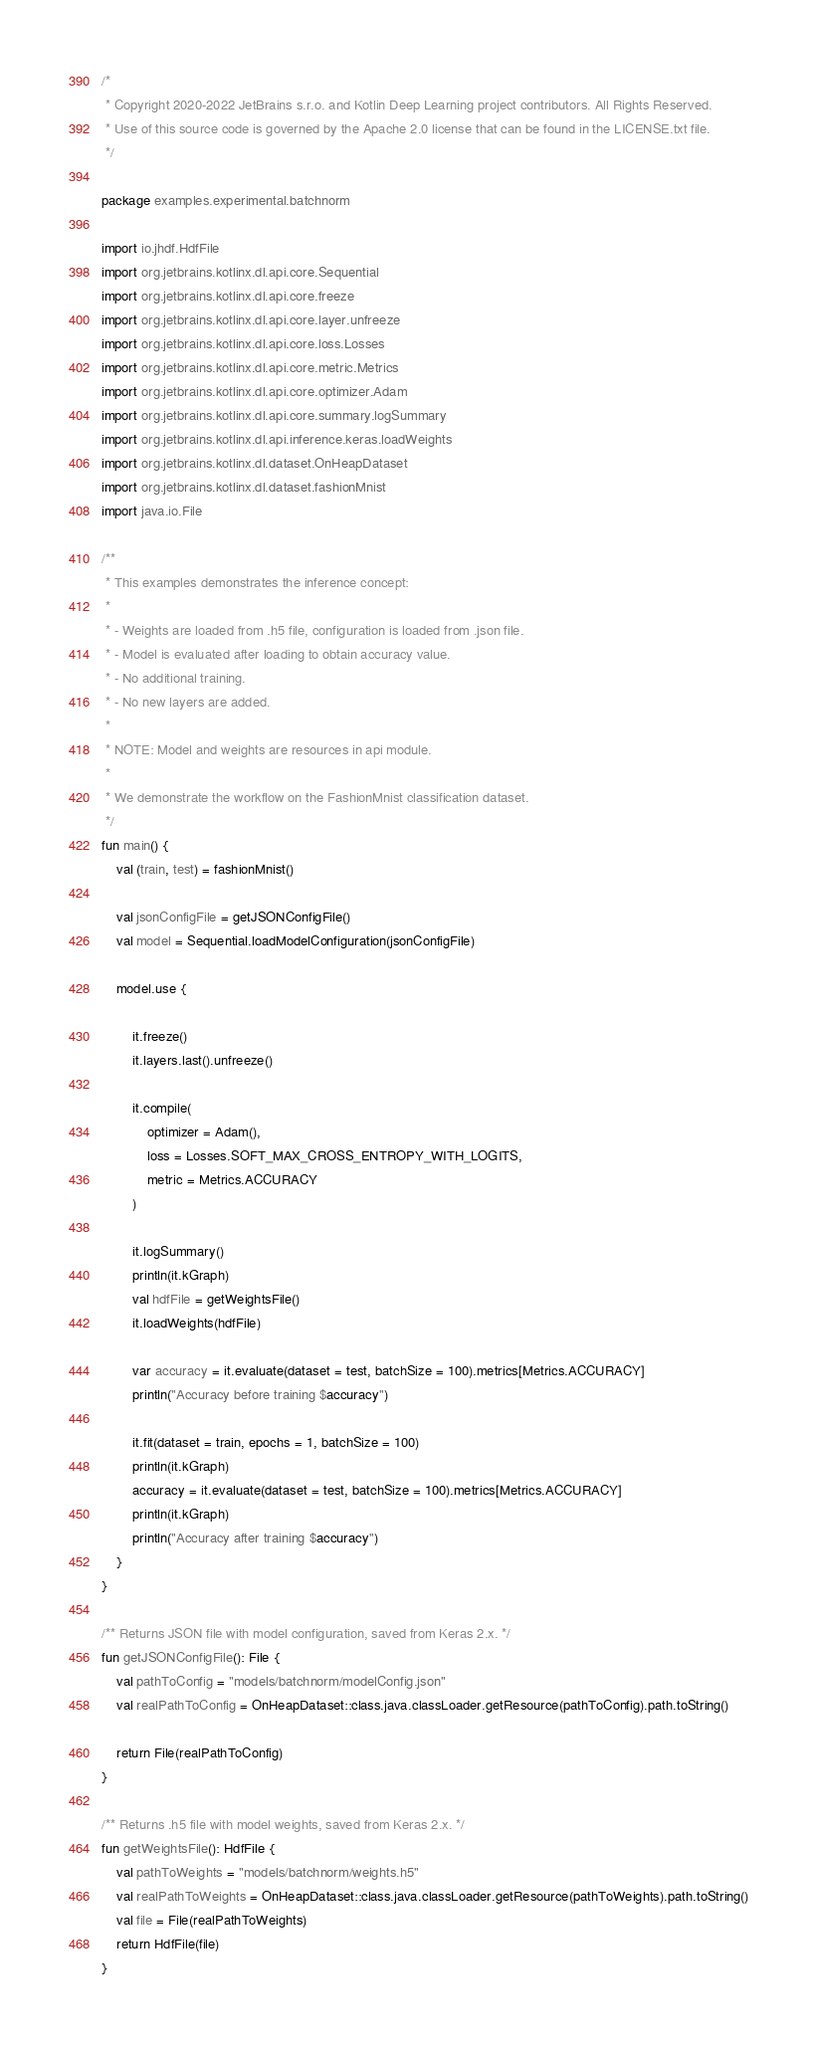<code> <loc_0><loc_0><loc_500><loc_500><_Kotlin_>/*
 * Copyright 2020-2022 JetBrains s.r.o. and Kotlin Deep Learning project contributors. All Rights Reserved.
 * Use of this source code is governed by the Apache 2.0 license that can be found in the LICENSE.txt file.
 */

package examples.experimental.batchnorm

import io.jhdf.HdfFile
import org.jetbrains.kotlinx.dl.api.core.Sequential
import org.jetbrains.kotlinx.dl.api.core.freeze
import org.jetbrains.kotlinx.dl.api.core.layer.unfreeze
import org.jetbrains.kotlinx.dl.api.core.loss.Losses
import org.jetbrains.kotlinx.dl.api.core.metric.Metrics
import org.jetbrains.kotlinx.dl.api.core.optimizer.Adam
import org.jetbrains.kotlinx.dl.api.core.summary.logSummary
import org.jetbrains.kotlinx.dl.api.inference.keras.loadWeights
import org.jetbrains.kotlinx.dl.dataset.OnHeapDataset
import org.jetbrains.kotlinx.dl.dataset.fashionMnist
import java.io.File

/**
 * This examples demonstrates the inference concept:
 *
 * - Weights are loaded from .h5 file, configuration is loaded from .json file.
 * - Model is evaluated after loading to obtain accuracy value.
 * - No additional training.
 * - No new layers are added.
 *
 * NOTE: Model and weights are resources in api module.
 *
 * We demonstrate the workflow on the FashionMnist classification dataset.
 */
fun main() {
    val (train, test) = fashionMnist()

    val jsonConfigFile = getJSONConfigFile()
    val model = Sequential.loadModelConfiguration(jsonConfigFile)

    model.use {

        it.freeze()
        it.layers.last().unfreeze()

        it.compile(
            optimizer = Adam(),
            loss = Losses.SOFT_MAX_CROSS_ENTROPY_WITH_LOGITS,
            metric = Metrics.ACCURACY
        )

        it.logSummary()
        println(it.kGraph)
        val hdfFile = getWeightsFile()
        it.loadWeights(hdfFile)

        var accuracy = it.evaluate(dataset = test, batchSize = 100).metrics[Metrics.ACCURACY]
        println("Accuracy before training $accuracy")

        it.fit(dataset = train, epochs = 1, batchSize = 100)
        println(it.kGraph)
        accuracy = it.evaluate(dataset = test, batchSize = 100).metrics[Metrics.ACCURACY]
        println(it.kGraph)
        println("Accuracy after training $accuracy")
    }
}

/** Returns JSON file with model configuration, saved from Keras 2.x. */
fun getJSONConfigFile(): File {
    val pathToConfig = "models/batchnorm/modelConfig.json"
    val realPathToConfig = OnHeapDataset::class.java.classLoader.getResource(pathToConfig).path.toString()

    return File(realPathToConfig)
}

/** Returns .h5 file with model weights, saved from Keras 2.x. */
fun getWeightsFile(): HdfFile {
    val pathToWeights = "models/batchnorm/weights.h5"
    val realPathToWeights = OnHeapDataset::class.java.classLoader.getResource(pathToWeights).path.toString()
    val file = File(realPathToWeights)
    return HdfFile(file)
}




</code> 